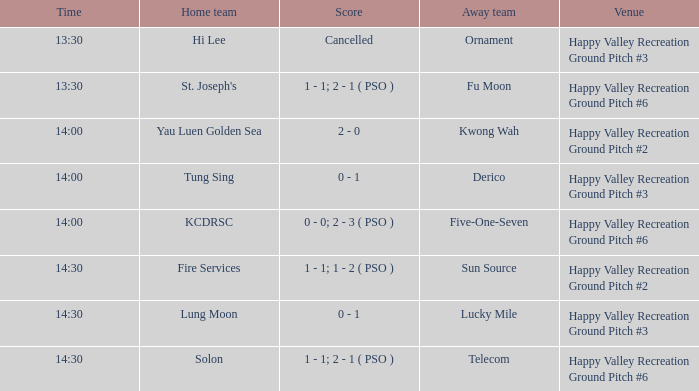Who was the visiting team when solon played as the home team? Telecom. 